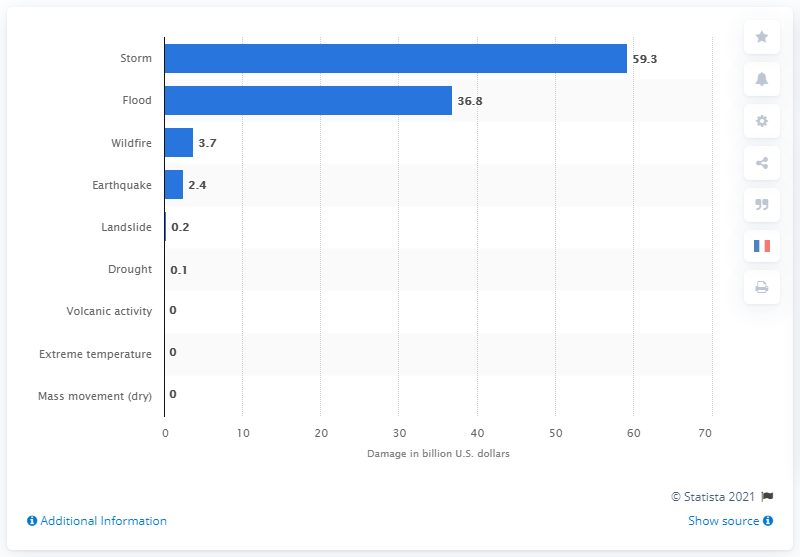Mention a couple of crucial points in this snapshot. In 2019, the value of damage caused by storms was 59.3 billion U.S. dollars. 